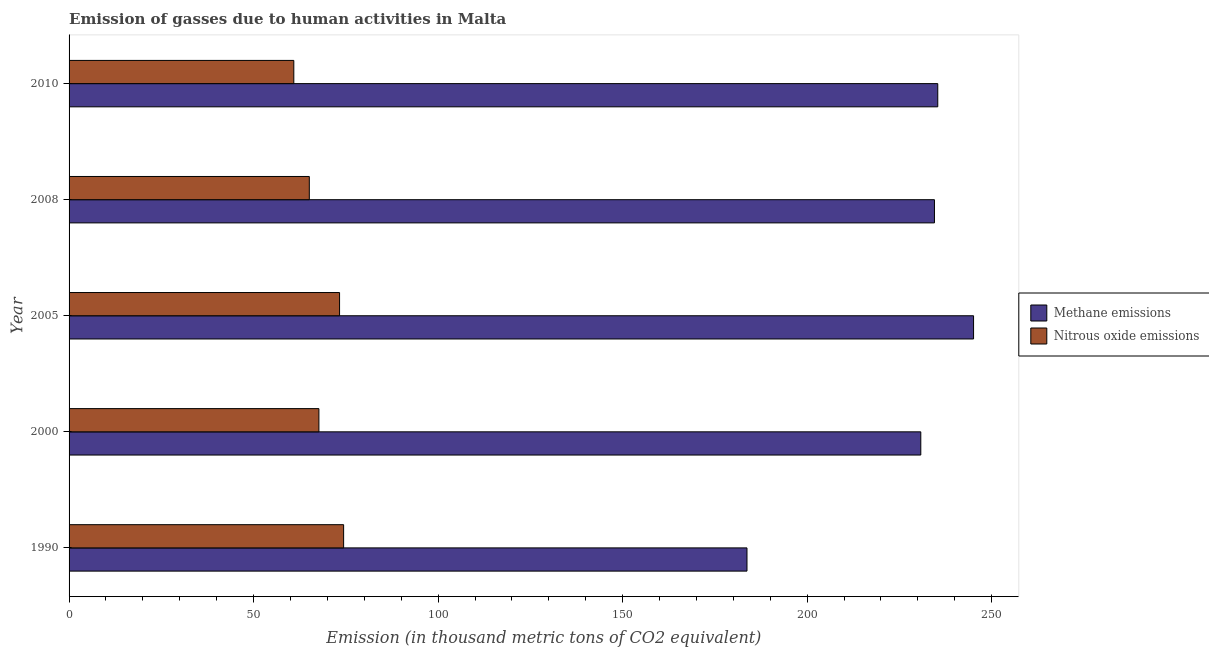How many different coloured bars are there?
Ensure brevity in your answer.  2. Are the number of bars per tick equal to the number of legend labels?
Make the answer very short. Yes. What is the label of the 3rd group of bars from the top?
Provide a short and direct response. 2005. In how many cases, is the number of bars for a given year not equal to the number of legend labels?
Give a very brief answer. 0. What is the amount of nitrous oxide emissions in 2008?
Your answer should be compact. 65.1. Across all years, what is the maximum amount of nitrous oxide emissions?
Your response must be concise. 74.4. Across all years, what is the minimum amount of nitrous oxide emissions?
Your answer should be very brief. 60.9. In which year was the amount of methane emissions maximum?
Ensure brevity in your answer.  2005. What is the total amount of nitrous oxide emissions in the graph?
Your response must be concise. 341.4. What is the difference between the amount of methane emissions in 1990 and that in 2010?
Your response must be concise. -51.7. What is the difference between the amount of methane emissions in 2000 and the amount of nitrous oxide emissions in 2010?
Offer a terse response. 169.9. What is the average amount of nitrous oxide emissions per year?
Your response must be concise. 68.28. In the year 2000, what is the difference between the amount of methane emissions and amount of nitrous oxide emissions?
Keep it short and to the point. 163.1. What is the ratio of the amount of nitrous oxide emissions in 2008 to that in 2010?
Offer a terse response. 1.07. Is the amount of methane emissions in 2000 less than that in 2005?
Make the answer very short. Yes. What is the difference between the highest and the lowest amount of methane emissions?
Give a very brief answer. 61.4. What does the 1st bar from the top in 1990 represents?
Provide a succinct answer. Nitrous oxide emissions. What does the 2nd bar from the bottom in 2000 represents?
Keep it short and to the point. Nitrous oxide emissions. How many years are there in the graph?
Provide a short and direct response. 5. Are the values on the major ticks of X-axis written in scientific E-notation?
Your answer should be very brief. No. Does the graph contain grids?
Your answer should be compact. No. Where does the legend appear in the graph?
Your answer should be compact. Center right. How many legend labels are there?
Your response must be concise. 2. What is the title of the graph?
Offer a terse response. Emission of gasses due to human activities in Malta. Does "Infant" appear as one of the legend labels in the graph?
Provide a short and direct response. No. What is the label or title of the X-axis?
Provide a short and direct response. Emission (in thousand metric tons of CO2 equivalent). What is the label or title of the Y-axis?
Your answer should be very brief. Year. What is the Emission (in thousand metric tons of CO2 equivalent) in Methane emissions in 1990?
Make the answer very short. 183.7. What is the Emission (in thousand metric tons of CO2 equivalent) of Nitrous oxide emissions in 1990?
Provide a short and direct response. 74.4. What is the Emission (in thousand metric tons of CO2 equivalent) in Methane emissions in 2000?
Make the answer very short. 230.8. What is the Emission (in thousand metric tons of CO2 equivalent) in Nitrous oxide emissions in 2000?
Ensure brevity in your answer.  67.7. What is the Emission (in thousand metric tons of CO2 equivalent) of Methane emissions in 2005?
Your answer should be very brief. 245.1. What is the Emission (in thousand metric tons of CO2 equivalent) of Nitrous oxide emissions in 2005?
Make the answer very short. 73.3. What is the Emission (in thousand metric tons of CO2 equivalent) in Methane emissions in 2008?
Your answer should be compact. 234.5. What is the Emission (in thousand metric tons of CO2 equivalent) in Nitrous oxide emissions in 2008?
Your answer should be very brief. 65.1. What is the Emission (in thousand metric tons of CO2 equivalent) of Methane emissions in 2010?
Your answer should be very brief. 235.4. What is the Emission (in thousand metric tons of CO2 equivalent) in Nitrous oxide emissions in 2010?
Ensure brevity in your answer.  60.9. Across all years, what is the maximum Emission (in thousand metric tons of CO2 equivalent) in Methane emissions?
Offer a very short reply. 245.1. Across all years, what is the maximum Emission (in thousand metric tons of CO2 equivalent) of Nitrous oxide emissions?
Your answer should be very brief. 74.4. Across all years, what is the minimum Emission (in thousand metric tons of CO2 equivalent) in Methane emissions?
Keep it short and to the point. 183.7. Across all years, what is the minimum Emission (in thousand metric tons of CO2 equivalent) of Nitrous oxide emissions?
Make the answer very short. 60.9. What is the total Emission (in thousand metric tons of CO2 equivalent) of Methane emissions in the graph?
Offer a very short reply. 1129.5. What is the total Emission (in thousand metric tons of CO2 equivalent) of Nitrous oxide emissions in the graph?
Offer a terse response. 341.4. What is the difference between the Emission (in thousand metric tons of CO2 equivalent) of Methane emissions in 1990 and that in 2000?
Keep it short and to the point. -47.1. What is the difference between the Emission (in thousand metric tons of CO2 equivalent) of Nitrous oxide emissions in 1990 and that in 2000?
Ensure brevity in your answer.  6.7. What is the difference between the Emission (in thousand metric tons of CO2 equivalent) of Methane emissions in 1990 and that in 2005?
Give a very brief answer. -61.4. What is the difference between the Emission (in thousand metric tons of CO2 equivalent) in Methane emissions in 1990 and that in 2008?
Provide a short and direct response. -50.8. What is the difference between the Emission (in thousand metric tons of CO2 equivalent) of Methane emissions in 1990 and that in 2010?
Your answer should be compact. -51.7. What is the difference between the Emission (in thousand metric tons of CO2 equivalent) in Methane emissions in 2000 and that in 2005?
Make the answer very short. -14.3. What is the difference between the Emission (in thousand metric tons of CO2 equivalent) of Nitrous oxide emissions in 2000 and that in 2008?
Your response must be concise. 2.6. What is the difference between the Emission (in thousand metric tons of CO2 equivalent) of Nitrous oxide emissions in 2000 and that in 2010?
Make the answer very short. 6.8. What is the difference between the Emission (in thousand metric tons of CO2 equivalent) in Nitrous oxide emissions in 2005 and that in 2008?
Your response must be concise. 8.2. What is the difference between the Emission (in thousand metric tons of CO2 equivalent) of Methane emissions in 2008 and that in 2010?
Provide a succinct answer. -0.9. What is the difference between the Emission (in thousand metric tons of CO2 equivalent) of Methane emissions in 1990 and the Emission (in thousand metric tons of CO2 equivalent) of Nitrous oxide emissions in 2000?
Your answer should be compact. 116. What is the difference between the Emission (in thousand metric tons of CO2 equivalent) of Methane emissions in 1990 and the Emission (in thousand metric tons of CO2 equivalent) of Nitrous oxide emissions in 2005?
Offer a terse response. 110.4. What is the difference between the Emission (in thousand metric tons of CO2 equivalent) of Methane emissions in 1990 and the Emission (in thousand metric tons of CO2 equivalent) of Nitrous oxide emissions in 2008?
Your answer should be very brief. 118.6. What is the difference between the Emission (in thousand metric tons of CO2 equivalent) in Methane emissions in 1990 and the Emission (in thousand metric tons of CO2 equivalent) in Nitrous oxide emissions in 2010?
Your answer should be compact. 122.8. What is the difference between the Emission (in thousand metric tons of CO2 equivalent) in Methane emissions in 2000 and the Emission (in thousand metric tons of CO2 equivalent) in Nitrous oxide emissions in 2005?
Your answer should be very brief. 157.5. What is the difference between the Emission (in thousand metric tons of CO2 equivalent) of Methane emissions in 2000 and the Emission (in thousand metric tons of CO2 equivalent) of Nitrous oxide emissions in 2008?
Make the answer very short. 165.7. What is the difference between the Emission (in thousand metric tons of CO2 equivalent) of Methane emissions in 2000 and the Emission (in thousand metric tons of CO2 equivalent) of Nitrous oxide emissions in 2010?
Ensure brevity in your answer.  169.9. What is the difference between the Emission (in thousand metric tons of CO2 equivalent) in Methane emissions in 2005 and the Emission (in thousand metric tons of CO2 equivalent) in Nitrous oxide emissions in 2008?
Offer a terse response. 180. What is the difference between the Emission (in thousand metric tons of CO2 equivalent) in Methane emissions in 2005 and the Emission (in thousand metric tons of CO2 equivalent) in Nitrous oxide emissions in 2010?
Offer a terse response. 184.2. What is the difference between the Emission (in thousand metric tons of CO2 equivalent) in Methane emissions in 2008 and the Emission (in thousand metric tons of CO2 equivalent) in Nitrous oxide emissions in 2010?
Make the answer very short. 173.6. What is the average Emission (in thousand metric tons of CO2 equivalent) of Methane emissions per year?
Ensure brevity in your answer.  225.9. What is the average Emission (in thousand metric tons of CO2 equivalent) of Nitrous oxide emissions per year?
Your answer should be compact. 68.28. In the year 1990, what is the difference between the Emission (in thousand metric tons of CO2 equivalent) in Methane emissions and Emission (in thousand metric tons of CO2 equivalent) in Nitrous oxide emissions?
Your response must be concise. 109.3. In the year 2000, what is the difference between the Emission (in thousand metric tons of CO2 equivalent) of Methane emissions and Emission (in thousand metric tons of CO2 equivalent) of Nitrous oxide emissions?
Ensure brevity in your answer.  163.1. In the year 2005, what is the difference between the Emission (in thousand metric tons of CO2 equivalent) of Methane emissions and Emission (in thousand metric tons of CO2 equivalent) of Nitrous oxide emissions?
Offer a very short reply. 171.8. In the year 2008, what is the difference between the Emission (in thousand metric tons of CO2 equivalent) of Methane emissions and Emission (in thousand metric tons of CO2 equivalent) of Nitrous oxide emissions?
Provide a succinct answer. 169.4. In the year 2010, what is the difference between the Emission (in thousand metric tons of CO2 equivalent) in Methane emissions and Emission (in thousand metric tons of CO2 equivalent) in Nitrous oxide emissions?
Make the answer very short. 174.5. What is the ratio of the Emission (in thousand metric tons of CO2 equivalent) of Methane emissions in 1990 to that in 2000?
Offer a very short reply. 0.8. What is the ratio of the Emission (in thousand metric tons of CO2 equivalent) in Nitrous oxide emissions in 1990 to that in 2000?
Ensure brevity in your answer.  1.1. What is the ratio of the Emission (in thousand metric tons of CO2 equivalent) of Methane emissions in 1990 to that in 2005?
Offer a very short reply. 0.75. What is the ratio of the Emission (in thousand metric tons of CO2 equivalent) of Nitrous oxide emissions in 1990 to that in 2005?
Keep it short and to the point. 1.01. What is the ratio of the Emission (in thousand metric tons of CO2 equivalent) in Methane emissions in 1990 to that in 2008?
Your answer should be very brief. 0.78. What is the ratio of the Emission (in thousand metric tons of CO2 equivalent) in Nitrous oxide emissions in 1990 to that in 2008?
Offer a very short reply. 1.14. What is the ratio of the Emission (in thousand metric tons of CO2 equivalent) of Methane emissions in 1990 to that in 2010?
Offer a terse response. 0.78. What is the ratio of the Emission (in thousand metric tons of CO2 equivalent) of Nitrous oxide emissions in 1990 to that in 2010?
Ensure brevity in your answer.  1.22. What is the ratio of the Emission (in thousand metric tons of CO2 equivalent) in Methane emissions in 2000 to that in 2005?
Provide a short and direct response. 0.94. What is the ratio of the Emission (in thousand metric tons of CO2 equivalent) of Nitrous oxide emissions in 2000 to that in 2005?
Provide a short and direct response. 0.92. What is the ratio of the Emission (in thousand metric tons of CO2 equivalent) of Methane emissions in 2000 to that in 2008?
Your answer should be very brief. 0.98. What is the ratio of the Emission (in thousand metric tons of CO2 equivalent) of Nitrous oxide emissions in 2000 to that in 2008?
Give a very brief answer. 1.04. What is the ratio of the Emission (in thousand metric tons of CO2 equivalent) of Methane emissions in 2000 to that in 2010?
Provide a succinct answer. 0.98. What is the ratio of the Emission (in thousand metric tons of CO2 equivalent) of Nitrous oxide emissions in 2000 to that in 2010?
Your response must be concise. 1.11. What is the ratio of the Emission (in thousand metric tons of CO2 equivalent) in Methane emissions in 2005 to that in 2008?
Your answer should be compact. 1.05. What is the ratio of the Emission (in thousand metric tons of CO2 equivalent) of Nitrous oxide emissions in 2005 to that in 2008?
Your answer should be very brief. 1.13. What is the ratio of the Emission (in thousand metric tons of CO2 equivalent) in Methane emissions in 2005 to that in 2010?
Provide a succinct answer. 1.04. What is the ratio of the Emission (in thousand metric tons of CO2 equivalent) in Nitrous oxide emissions in 2005 to that in 2010?
Give a very brief answer. 1.2. What is the ratio of the Emission (in thousand metric tons of CO2 equivalent) of Nitrous oxide emissions in 2008 to that in 2010?
Make the answer very short. 1.07. What is the difference between the highest and the second highest Emission (in thousand metric tons of CO2 equivalent) of Nitrous oxide emissions?
Offer a terse response. 1.1. What is the difference between the highest and the lowest Emission (in thousand metric tons of CO2 equivalent) in Methane emissions?
Make the answer very short. 61.4. 